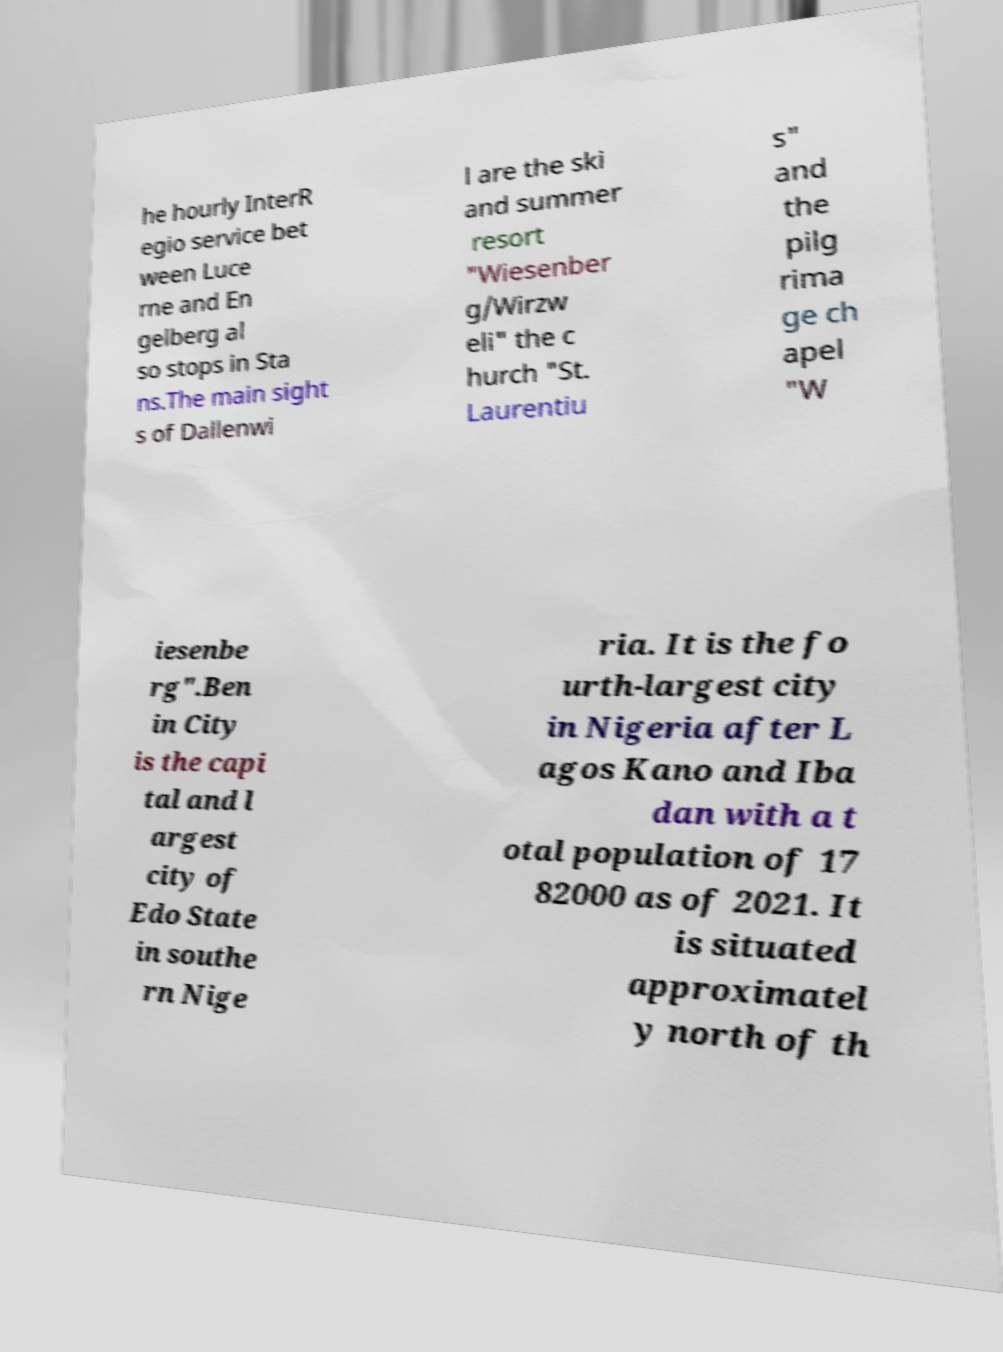Please read and relay the text visible in this image. What does it say? he hourly InterR egio service bet ween Luce rne and En gelberg al so stops in Sta ns.The main sight s of Dallenwi l are the ski and summer resort "Wiesenber g/Wirzw eli" the c hurch "St. Laurentiu s" and the pilg rima ge ch apel "W iesenbe rg".Ben in City is the capi tal and l argest city of Edo State in southe rn Nige ria. It is the fo urth-largest city in Nigeria after L agos Kano and Iba dan with a t otal population of 17 82000 as of 2021. It is situated approximatel y north of th 